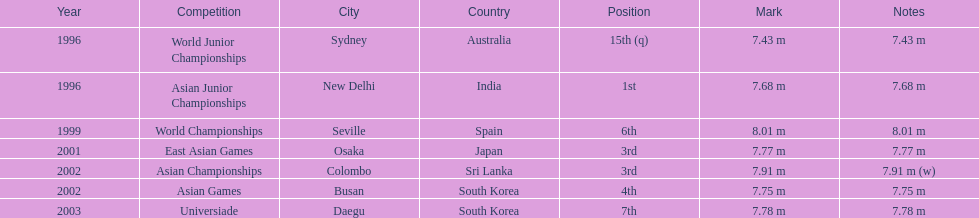Could you parse the entire table? {'header': ['Year', 'Competition', 'City', 'Country', 'Position', 'Mark', 'Notes'], 'rows': [['1996', 'World Junior Championships', 'Sydney', 'Australia', '15th (q)', '7.43 m', '7.43 m'], ['1996', 'Asian Junior Championships', 'New Delhi', 'India', '1st', '7.68 m', '7.68 m'], ['1999', 'World Championships', 'Seville', 'Spain', '6th', '8.01 m', '8.01 m'], ['2001', 'East Asian Games', 'Osaka', 'Japan', '3rd', '7.77 m', '7.77 m'], ['2002', 'Asian Championships', 'Colombo', 'Sri Lanka', '3rd', '7.91 m', '7.91 m (w)'], ['2002', 'Asian Games', 'Busan', 'South Korea', '4th', '7.75 m', '7.75 m'], ['2003', 'Universiade', 'Daegu', 'South Korea', '7th', '7.78 m', '7.78 m']]} How many total competitions were in south korea? 2. 